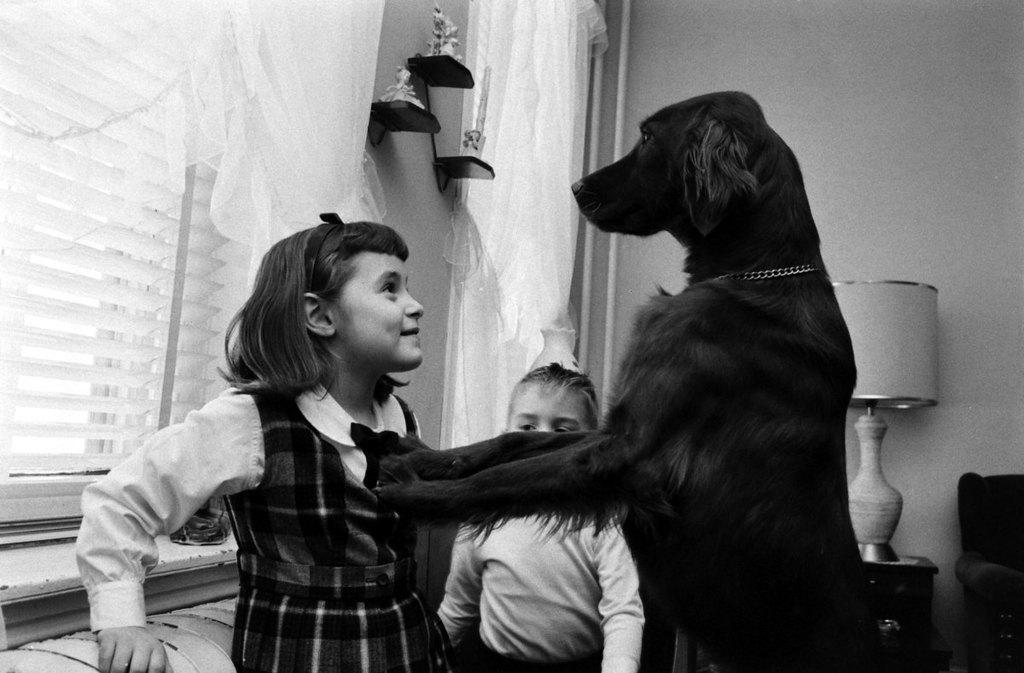How many children are in the image? There are 2 children in the image. What is the emotional expression of the girl in the image? The girl is smiling. What type of animal is present in the image? There is a dog in the image. What can be seen in the background of the image? There are windows, a curtain, a lamp, and other unspecified objects in the background of the image. What is the wall's purpose in the image? The wall serves as a background element in the image. What type of pies are being sold at the camp in the image? There is no camp or pies present in the image; it features 2 children, a dog, and a background with windows, a curtain, a lamp, and other unspecified objects. Can you tell me how many animals are in the zoo in the image? There is no zoo or animals present in the image; it features 2 children, a dog, and a background with windows, a curtain, a lamp, and other unspecified objects. 